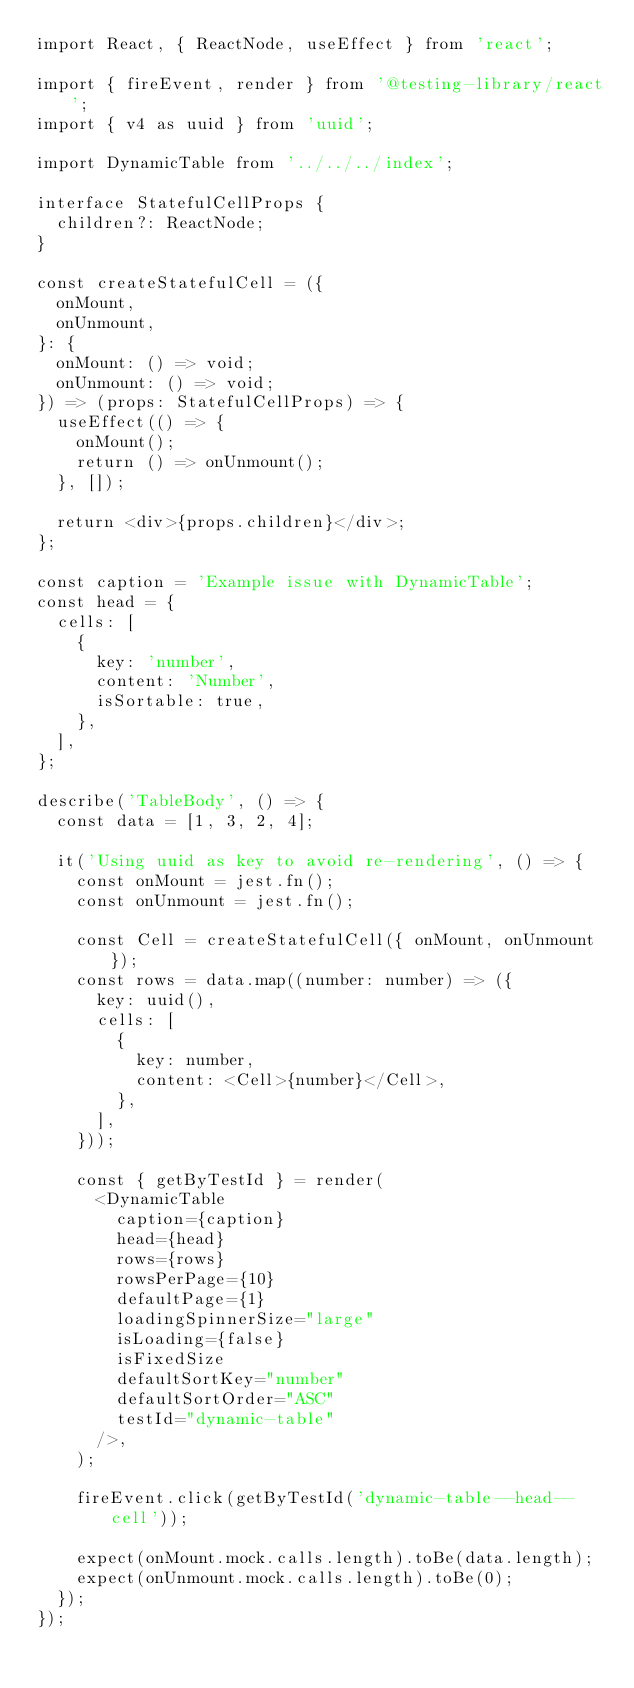<code> <loc_0><loc_0><loc_500><loc_500><_TypeScript_>import React, { ReactNode, useEffect } from 'react';

import { fireEvent, render } from '@testing-library/react';
import { v4 as uuid } from 'uuid';

import DynamicTable from '../../../index';

interface StatefulCellProps {
  children?: ReactNode;
}

const createStatefulCell = ({
  onMount,
  onUnmount,
}: {
  onMount: () => void;
  onUnmount: () => void;
}) => (props: StatefulCellProps) => {
  useEffect(() => {
    onMount();
    return () => onUnmount();
  }, []);

  return <div>{props.children}</div>;
};

const caption = 'Example issue with DynamicTable';
const head = {
  cells: [
    {
      key: 'number',
      content: 'Number',
      isSortable: true,
    },
  ],
};

describe('TableBody', () => {
  const data = [1, 3, 2, 4];

  it('Using uuid as key to avoid re-rendering', () => {
    const onMount = jest.fn();
    const onUnmount = jest.fn();

    const Cell = createStatefulCell({ onMount, onUnmount });
    const rows = data.map((number: number) => ({
      key: uuid(),
      cells: [
        {
          key: number,
          content: <Cell>{number}</Cell>,
        },
      ],
    }));

    const { getByTestId } = render(
      <DynamicTable
        caption={caption}
        head={head}
        rows={rows}
        rowsPerPage={10}
        defaultPage={1}
        loadingSpinnerSize="large"
        isLoading={false}
        isFixedSize
        defaultSortKey="number"
        defaultSortOrder="ASC"
        testId="dynamic-table"
      />,
    );

    fireEvent.click(getByTestId('dynamic-table--head--cell'));

    expect(onMount.mock.calls.length).toBe(data.length);
    expect(onUnmount.mock.calls.length).toBe(0);
  });
});
</code> 